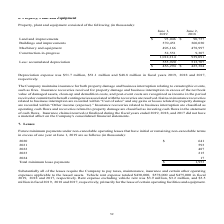According to Cal Maine Foods's financial document, What was the depreciation expense in 2019? According to the financial document, $51.7 million. The relevant text states: "Depreciation expense was $51.7 million, $51.1 million and $48.8 million in fiscal years 2019, 2018 and 2017, respectively...." Also, can you calculate: What is the average building and improvements? To answer this question, I need to perform calculations using the financial data. The calculation is: (370,451 + 360,030) / 2, which equals 365240.5 (in thousands). This is based on the information: "3,046 $ 90,757 Buildings and improvements 370,451 360,030 Machinery and equipment 496,166 478,997 Construction-in-progress 52,551 9,307 1,012,214 939,091 Les ents $ 93,046 $ 90,757 Buildings and impro..." The key data points involved are: 360,030, 370,451. Also, can you calculate: What is the percentage increase in accumulated depreciation from 2018 to 2019? To answer this question, I need to perform calculations using the financial data. The calculation is: 555,920 / 513,707 - 1, which equals 8.22 (percentage). This is based on the information: "14 939,091 Less: accumulated depreciation 555,920 513,707 $ 456,294 $ 425,384 1,012,214 939,091 Less: accumulated depreciation 555,920 513,707 $ 456,294 $ 425,384..." The key data points involved are: 513,707, 555,920. Also, can you calculate: What is the average land and improvements? To answer this question, I need to perform calculations using the financial data. The calculation is: (93,046 + 90,757) / 2, which equals 91901.5 (in thousands). This is based on the information: "June 1, 2019 June 2, 2018 Land and improvements $ 93,046 $ 90,757 Buildings and improvements 370,451 360,030 Machinery and equipment 496,166 478,997 Constru 019 June 2, 2018 Land and improvements $ 93..." The key data points involved are: 90,757, 93,046. Also, What are insurance recoveries related to business interruption classified as? operating cash flows. The document states: "elated to business interruption are classified as operating cash flows and recoveries related to property damage are classified as investing cash flow..." Also, What are recoveries related to property damage are classified as? investing cash flows. The document states: "ries related to property damage are classified as investing cash flows in the statement of cash flows. Insurance claims incurred or finalized during t..." 